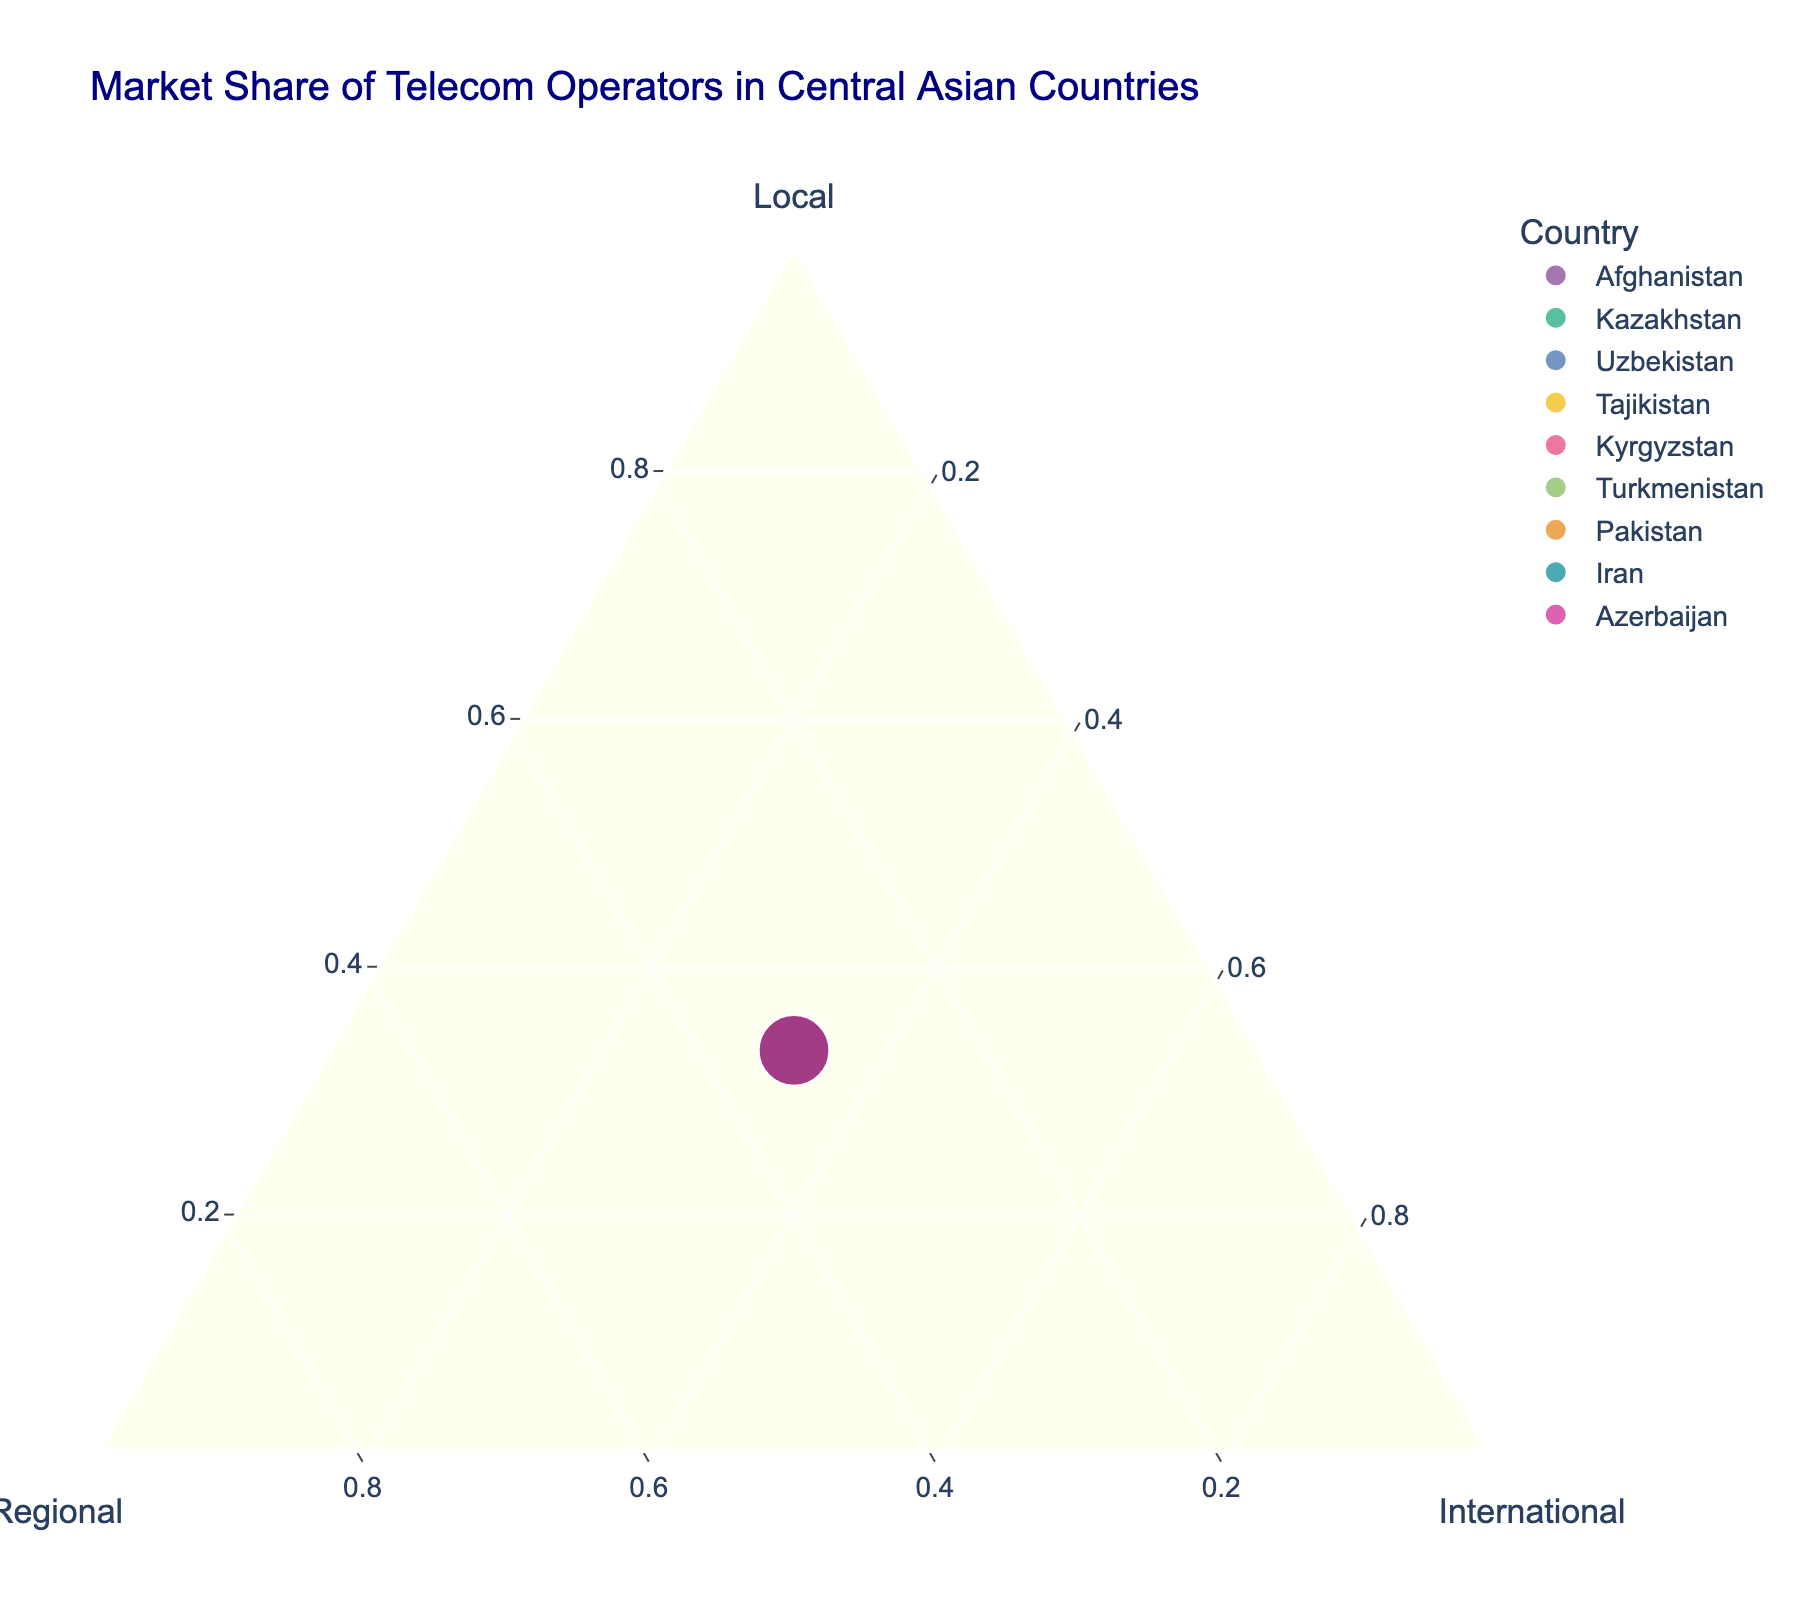what is the title of the plot? The title is usually displayed prominently at the top of the figure. In this case, it is stated in the code.
Answer: Market Share of Telecom Operators in Central Asian Countries How many countries are represented in the plot? Based on the data provided, we have one data point for each country. Count the number of unique countries listed.
Answer: 9 Which country uses Afghan Wireless as a local operator? Look at the hover labels on the plot or check the data where Afghan Wireless is listed as the local operator.
Answer: Afghanistan What are the titles of the three axes? Each axis in a ternary plot represents a different category. Based on the plot code, the three axes are clearly labeled.
Answer: Local, Regional, International What is the position of Pakistan in terms of local operators? In a ternary plot, each vertex represents 100% of the corresponding category. Pakistan’s position in the local operator category should be observed.
Answer: 33.33% Which country has ZET-Mobile as an international operator? The hover labels on the plot or reference the data listing ZET-Mobile as the international operator.
Answer: Tajikistan Compare the market share positions of Iran and Kazakhstan. Who has an equal share across all three categories? Iran and Kazakhstan both fall at the center of the ternary plot, indicating an equal market share in Local, Regional, and International categories.
Answer: Both For challenging questions, compare the market share of Uzbekistan and Turkmenistan in international operators. Who has a higher share? Calculate the exact position of Uzbekistan and Turkmenistan in the International vertex of the ternary plot. Since the shares are simplified as equal in this plot, it is a conceptual comparison based on the actual operator names and finding differences in position deviations.
Answer: Equal Which country's local operator falls closest to 33.33% on the plot? Because of visual distribution around the Local vertex where 33.33% is considered evenly distributed, check for the nearest points around that.
Answer: All countries (since the data is made equal for simplicity) 